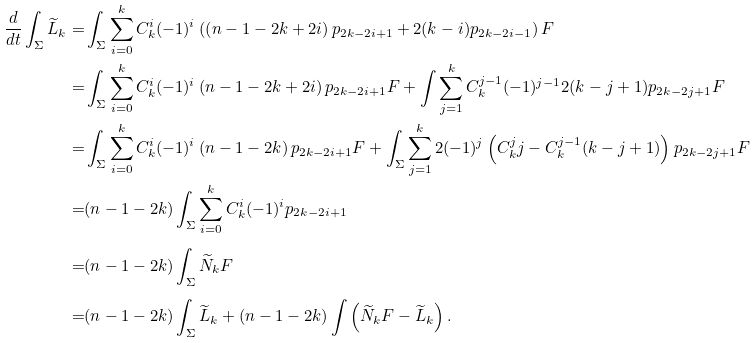<formula> <loc_0><loc_0><loc_500><loc_500>\frac { d } { d t } \int _ { \Sigma } \widetilde { L } _ { k } = & \int _ { \Sigma } \sum _ { i = 0 } ^ { k } C _ { k } ^ { i } ( - 1 ) ^ { i } \left ( \left ( n - 1 - 2 k + 2 i \right ) p _ { 2 k - 2 i + 1 } + 2 ( k - i ) p _ { 2 k - 2 i - 1 } \right ) F \\ = & \int _ { \Sigma } \sum _ { i = 0 } ^ { k } C _ { k } ^ { i } ( - 1 ) ^ { i } \left ( n - 1 - 2 k + 2 i \right ) p _ { 2 k - 2 i + 1 } F + \int \sum _ { j = 1 } ^ { k } C _ { k } ^ { j - 1 } ( - 1 ) ^ { j - 1 } 2 ( k - j + 1 ) p _ { 2 k - 2 j + 1 } F \\ = & \int _ { \Sigma } \sum _ { i = 0 } ^ { k } C _ { k } ^ { i } ( - 1 ) ^ { i } \left ( n - 1 - 2 k \right ) p _ { 2 k - 2 i + 1 } F + \int _ { \Sigma } \sum _ { j = 1 } ^ { k } 2 ( - 1 ) ^ { j } \left ( C _ { k } ^ { j } j - C _ { k } ^ { j - 1 } ( k - j + 1 ) \right ) p _ { 2 k - 2 j + 1 } F \\ = & ( n - 1 - 2 k ) \int _ { \Sigma } \sum _ { i = 0 } ^ { k } C _ { k } ^ { i } ( - 1 ) ^ { i } p _ { 2 k - 2 i + 1 } \\ = & ( n - 1 - 2 k ) \int _ { \Sigma } \widetilde { N } _ { k } F \\ = & ( n - 1 - 2 k ) \int _ { \Sigma } \widetilde { L } _ { k } + ( n - 1 - 2 k ) \int \left ( \widetilde { N } _ { k } F - \widetilde { L } _ { k } \right ) .</formula> 